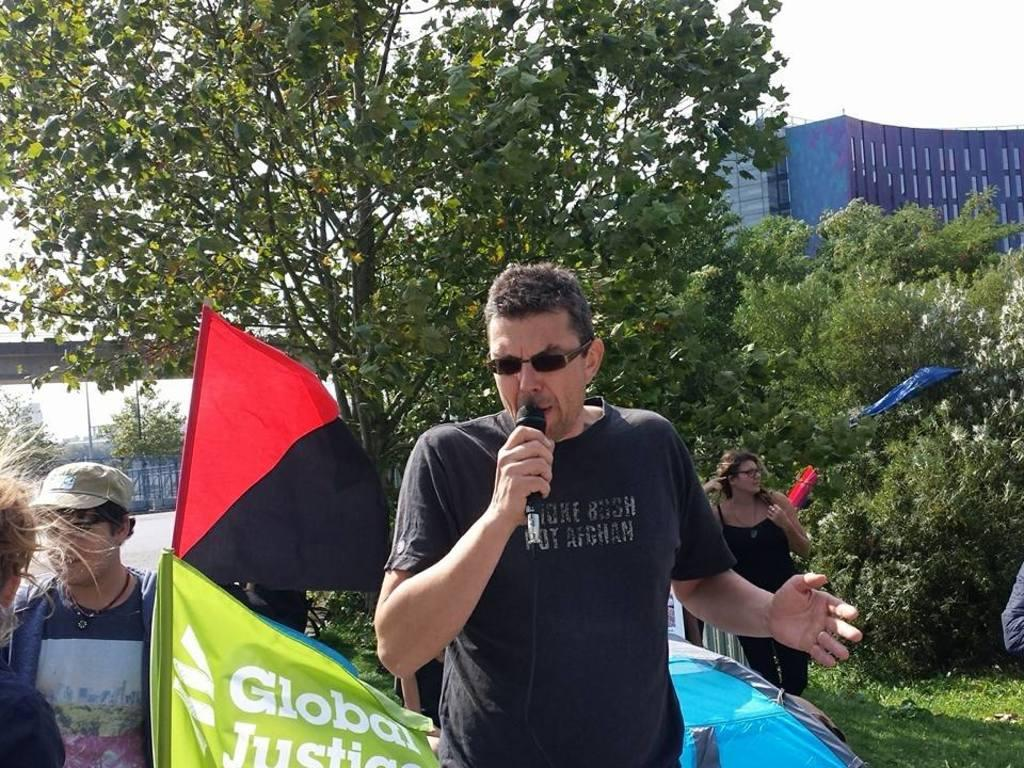How many people are in the image? There are people in the image, but the exact number is not specified. What type of natural elements can be seen in the image? There are trees in the image. What type of man-made structures are present in the image? There are buildings in the image. What additional objects can be seen in the image? There are flags in the image. What is the person holding in the image? The person is holding a microphone. What accessory is the person wearing in the image? The person is wearing sunglasses. What type of written information is visible in the image? There is text visible in the image. How many cubs are playing with the tree in the image? There are no cubs or trees present in the image. What type of cord is being used to hold the microphone in the image? There is no cord visible in the image; the person is holding the microphone directly. 